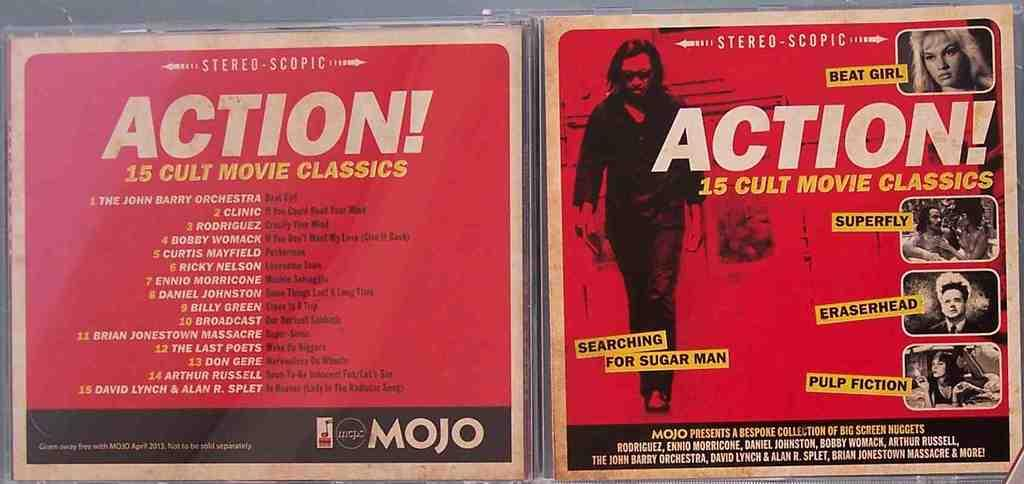<image>
Summarize the visual content of the image. Cover showing a man walking for "Action! 15 Cult Movie Classics" 